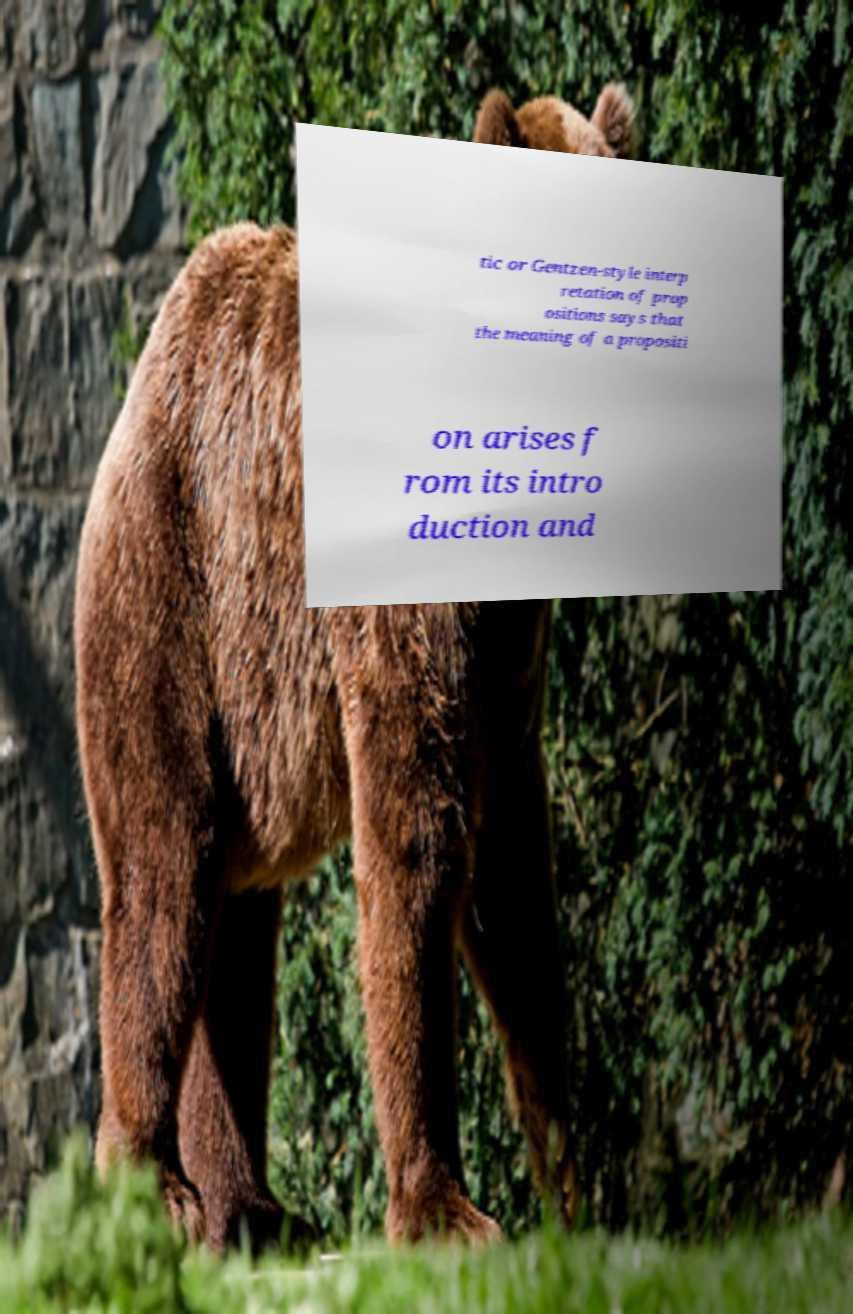Can you accurately transcribe the text from the provided image for me? tic or Gentzen-style interp retation of prop ositions says that the meaning of a propositi on arises f rom its intro duction and 